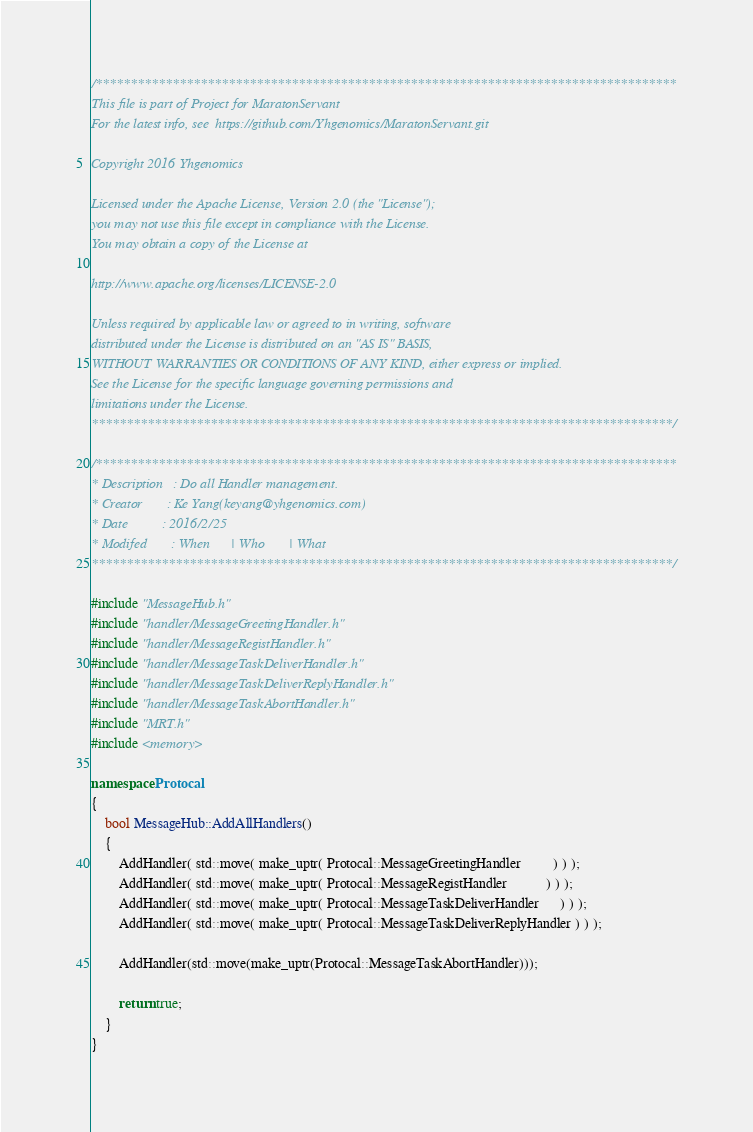<code> <loc_0><loc_0><loc_500><loc_500><_C++_>/***********************************************************************************
This file is part of Project for MaratonServant
For the latest info, see  https://github.com/Yhgenomics/MaratonServant.git

Copyright 2016 Yhgenomics

Licensed under the Apache License, Version 2.0 (the "License");
you may not use this file except in compliance with the License.
You may obtain a copy of the License at

http://www.apache.org/licenses/LICENSE-2.0

Unless required by applicable law or agreed to in writing, software
distributed under the License is distributed on an "AS IS" BASIS,
WITHOUT WARRANTIES OR CONDITIONS OF ANY KIND, either express or implied.
See the License for the specific language governing permissions and
limitations under the License.
***********************************************************************************/

/***********************************************************************************
* Description   : Do all Handler management.
* Creator       : Ke Yang(keyang@yhgenomics.com)
* Date          : 2016/2/25
* Modifed       : When      | Who       | What
***********************************************************************************/

#include "MessageHub.h"
#include "handler/MessageGreetingHandler.h"
#include "handler/MessageRegistHandler.h"
#include "handler/MessageTaskDeliverHandler.h"
#include "handler/MessageTaskDeliverReplyHandler.h"
#include "handler/MessageTaskAbortHandler.h"
#include "MRT.h"
#include <memory>

namespace Protocal
{
    bool MessageHub::AddAllHandlers()
    {
        AddHandler( std::move( make_uptr( Protocal::MessageGreetingHandler         ) ) );
        AddHandler( std::move( make_uptr( Protocal::MessageRegistHandler           ) ) );
        AddHandler( std::move( make_uptr( Protocal::MessageTaskDeliverHandler      ) ) );
        AddHandler( std::move( make_uptr( Protocal::MessageTaskDeliverReplyHandler ) ) );

        AddHandler(std::move(make_uptr(Protocal::MessageTaskAbortHandler)));

        return true;
    }
}</code> 